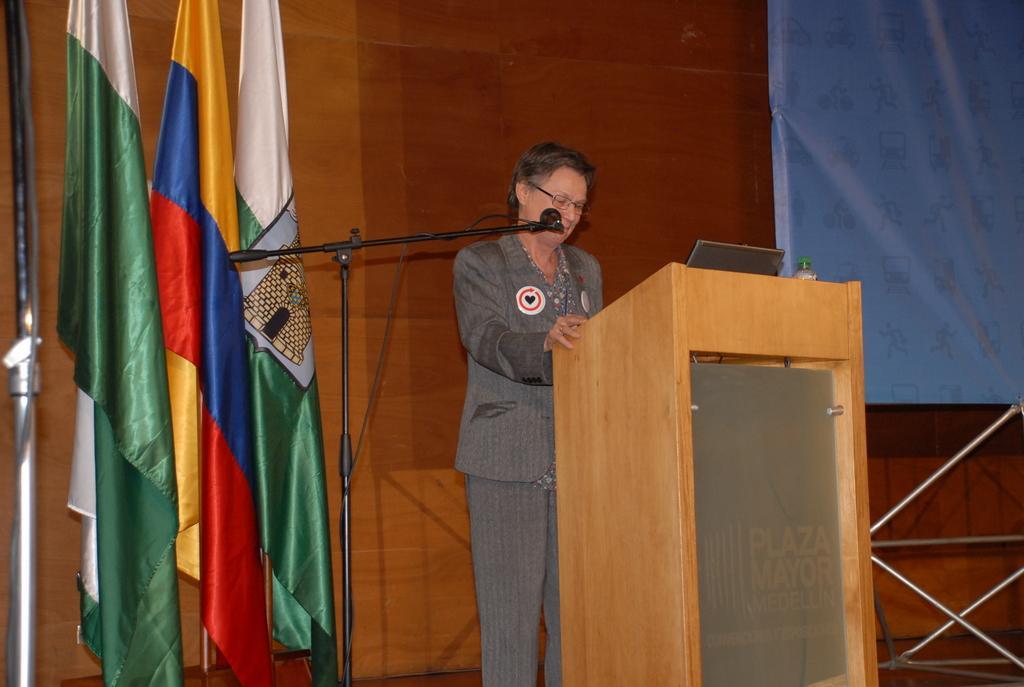How would you summarize this image in a sentence or two? In this image we can see a person wearing blazer and spectacles is standing near the wooden podium where a laptop and water bottle are placed. Here we can see the mic to the stand, flags to the pole, wooden wall and the banner here. 